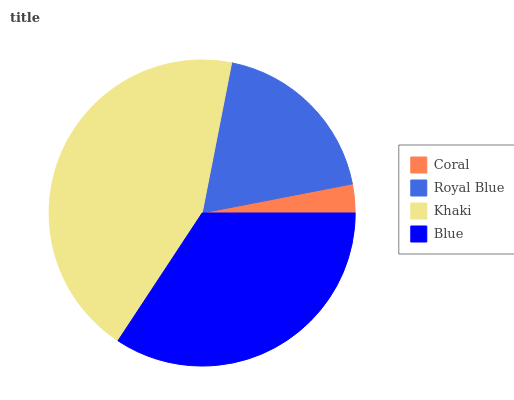Is Coral the minimum?
Answer yes or no. Yes. Is Khaki the maximum?
Answer yes or no. Yes. Is Royal Blue the minimum?
Answer yes or no. No. Is Royal Blue the maximum?
Answer yes or no. No. Is Royal Blue greater than Coral?
Answer yes or no. Yes. Is Coral less than Royal Blue?
Answer yes or no. Yes. Is Coral greater than Royal Blue?
Answer yes or no. No. Is Royal Blue less than Coral?
Answer yes or no. No. Is Blue the high median?
Answer yes or no. Yes. Is Royal Blue the low median?
Answer yes or no. Yes. Is Royal Blue the high median?
Answer yes or no. No. Is Coral the low median?
Answer yes or no. No. 